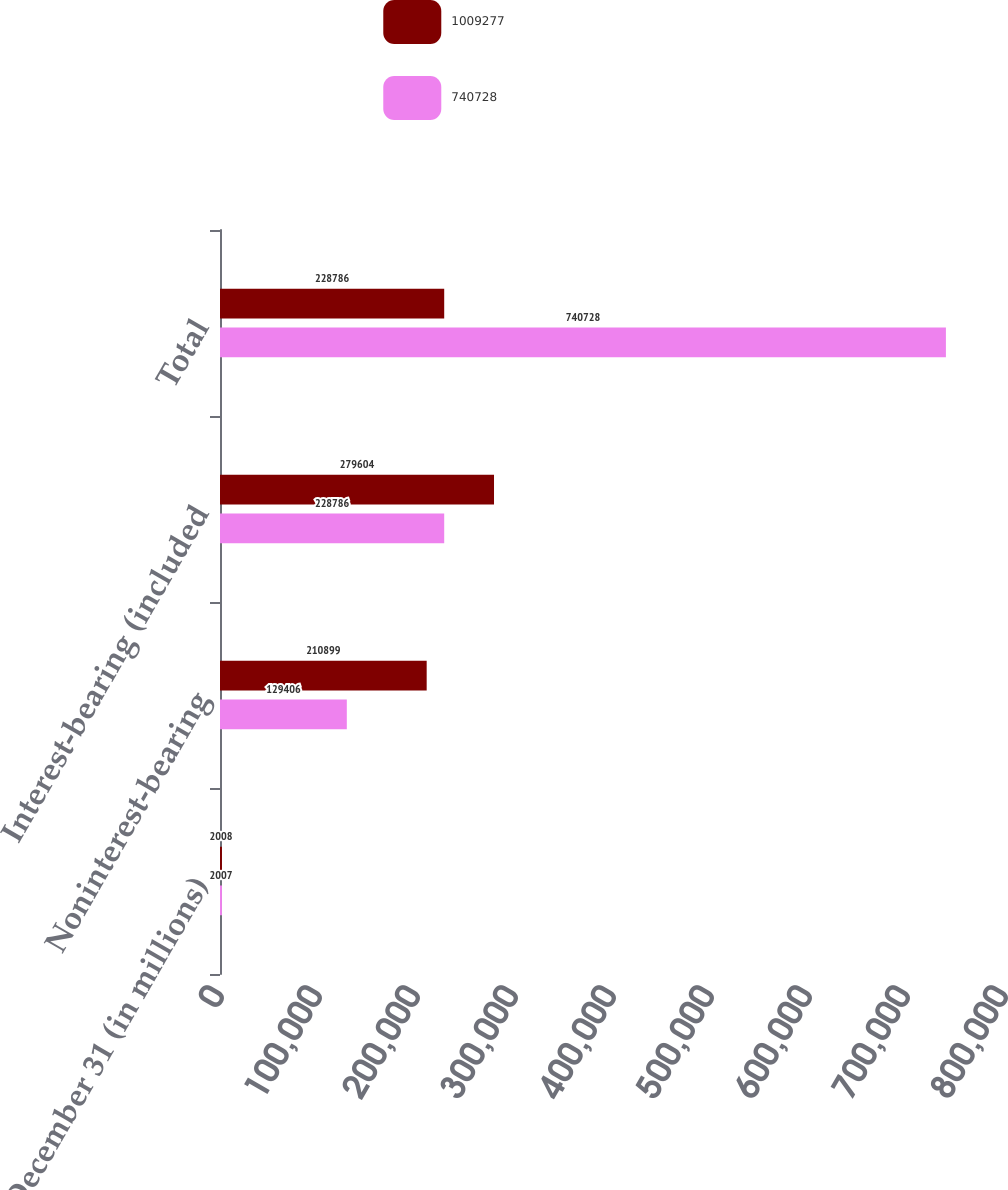<chart> <loc_0><loc_0><loc_500><loc_500><stacked_bar_chart><ecel><fcel>December 31 (in millions)<fcel>Noninterest-bearing<fcel>Interest-bearing (included<fcel>Total<nl><fcel>1.00928e+06<fcel>2008<fcel>210899<fcel>279604<fcel>228786<nl><fcel>740728<fcel>2007<fcel>129406<fcel>228786<fcel>740728<nl></chart> 